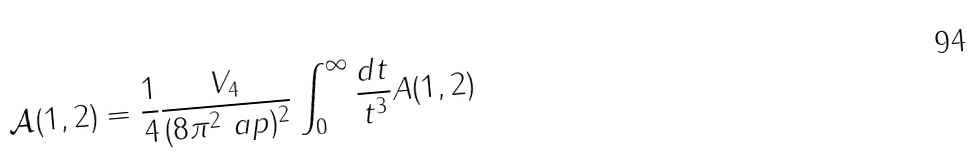<formula> <loc_0><loc_0><loc_500><loc_500>\mathcal { A } ( 1 , 2 ) = \frac { 1 } { 4 } \frac { V _ { 4 } } { ( 8 \pi ^ { 2 } \ a p ) ^ { 2 } } \int _ { 0 } ^ { \infty } \frac { d t } { t ^ { 3 } } A ( 1 , 2 )</formula> 